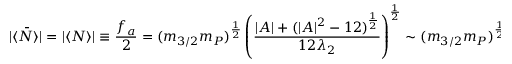Convert formula to latex. <formula><loc_0><loc_0><loc_500><loc_500>| \langle \bar { N } \rangle | = | \langle N \rangle | \equiv \frac { f _ { a } } { 2 } = ( m _ { 3 / 2 } m _ { P } ) ^ { \frac { 1 } { 2 } } \left ( \frac { | A | + ( | A | ^ { 2 } - 1 2 ) ^ { \frac { 1 } { 2 } } } { 1 2 \lambda _ { 2 } } \right ) ^ { \frac { 1 } { 2 } } \sim ( m _ { 3 / 2 } m _ { P } ) ^ { \frac { 1 } { 2 } } .</formula> 